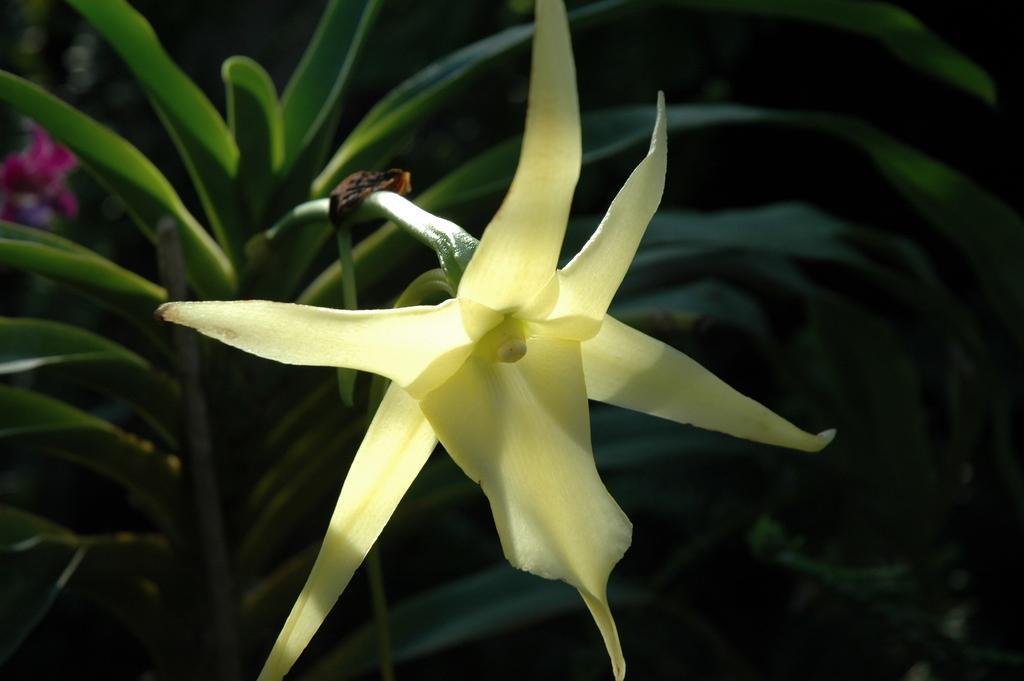In one or two sentences, can you explain what this image depicts? In this image, there are a few plants. Among them, we can see a flower and an object on one of the plants. 